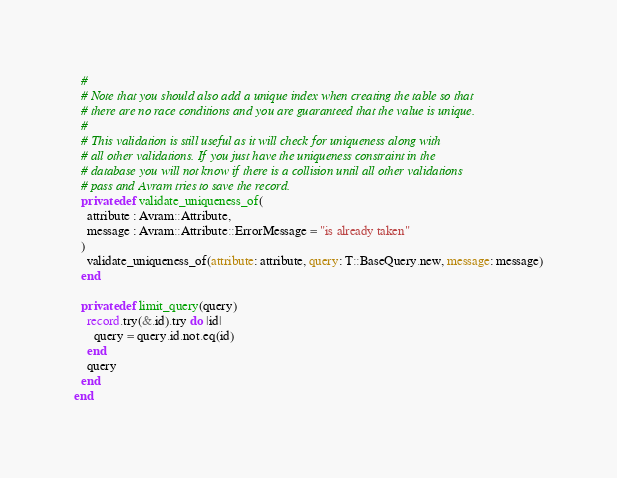Convert code to text. <code><loc_0><loc_0><loc_500><loc_500><_Crystal_>  #
  # Note that you should also add a unique index when creating the table so that
  # there are no race conditions and you are guaranteed that the value is unique.
  #
  # This validation is still useful as it will check for uniqueness along with
  # all other validations. If you just have the uniqueness constraint in the
  # database you will not know if there is a collision until all other validations
  # pass and Avram tries to save the record.
  private def validate_uniqueness_of(
    attribute : Avram::Attribute,
    message : Avram::Attribute::ErrorMessage = "is already taken"
  )
    validate_uniqueness_of(attribute: attribute, query: T::BaseQuery.new, message: message)
  end

  private def limit_query(query)
    record.try(&.id).try do |id|
      query = query.id.not.eq(id)
    end
    query
  end
end
</code> 